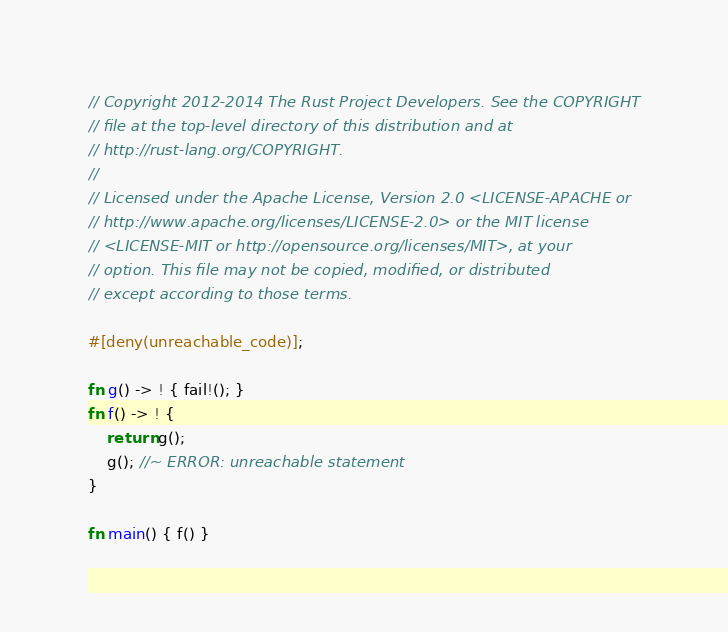<code> <loc_0><loc_0><loc_500><loc_500><_Rust_>// Copyright 2012-2014 The Rust Project Developers. See the COPYRIGHT
// file at the top-level directory of this distribution and at
// http://rust-lang.org/COPYRIGHT.
//
// Licensed under the Apache License, Version 2.0 <LICENSE-APACHE or
// http://www.apache.org/licenses/LICENSE-2.0> or the MIT license
// <LICENSE-MIT or http://opensource.org/licenses/MIT>, at your
// option. This file may not be copied, modified, or distributed
// except according to those terms.

#[deny(unreachable_code)];

fn g() -> ! { fail!(); }
fn f() -> ! {
    return g();
    g(); //~ ERROR: unreachable statement
}

fn main() { f() }
</code> 